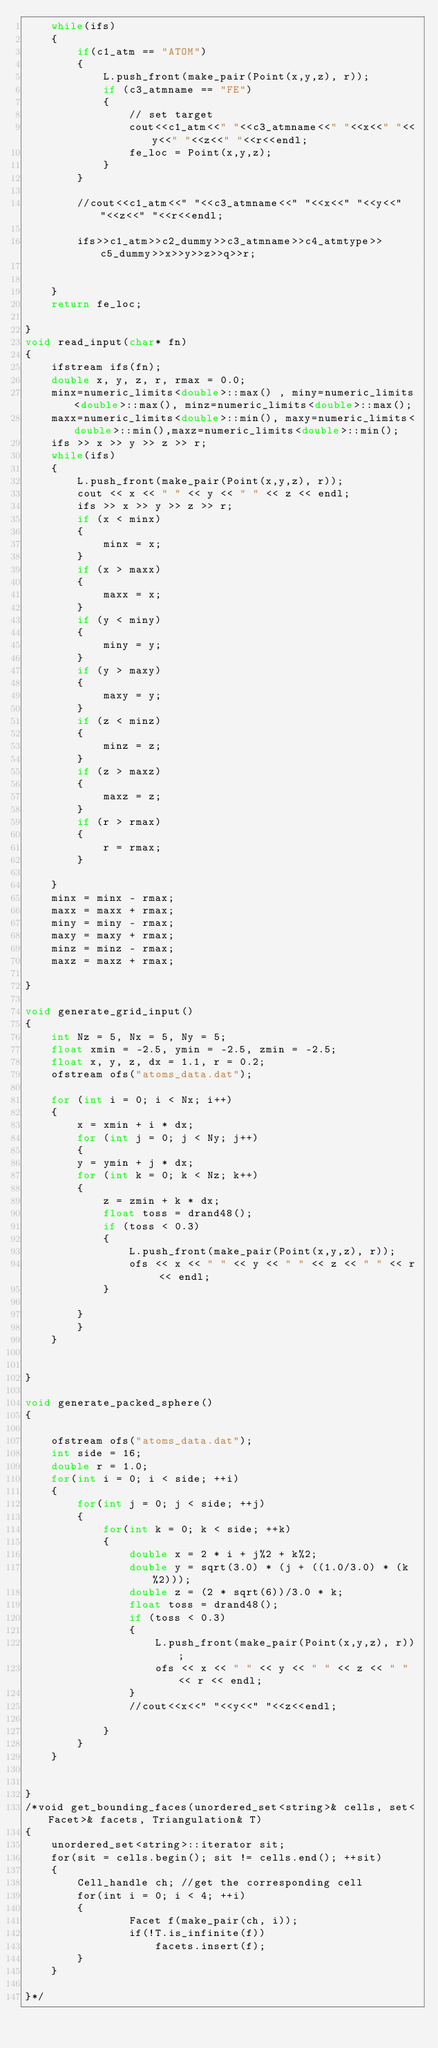<code> <loc_0><loc_0><loc_500><loc_500><_C++_>	while(ifs)
	{
		if(c1_atm == "ATOM")
		{
			L.push_front(make_pair(Point(x,y,z), r));
			if (c3_atmname == "FE")
			{
				// set target
				cout<<c1_atm<<" "<<c3_atmname<<" "<<x<<" "<<y<<" "<<z<<" "<<r<<endl;
				fe_loc = Point(x,y,z);
			}
		}
		
		//cout<<c1_atm<<" "<<c3_atmname<<" "<<x<<" "<<y<<" "<<z<<" "<<r<<endl;
		
		ifs>>c1_atm>>c2_dummy>>c3_atmname>>c4_atmtype>>c5_dummy>>x>>y>>z>>q>>r;


	}
	return fe_loc;

}
void read_input(char* fn)
{
	ifstream ifs(fn);
	double x, y, z, r, rmax = 0.0;
	minx=numeric_limits<double>::max() , miny=numeric_limits<double>::max(), minz=numeric_limits<double>::max();
	maxx=numeric_limits<double>::min(), maxy=numeric_limits<double>::min(),maxz=numeric_limits<double>::min();
	ifs >> x >> y >> z >> r;
	while(ifs)
	{
		L.push_front(make_pair(Point(x,y,z), r));
		cout << x << " " << y << " " << z << endl;
		ifs >> x >> y >> z >> r;
		if (x < minx)
		{
			minx = x;
		}
		if (x > maxx)
		{
			maxx = x;
		}
		if (y < miny)
		{
			miny = y;
		}
		if (y > maxy)
		{
			maxy = y;
		}
		if (z < minz)
		{
			minz = z;
		}
		if (z > maxz)
		{
			maxz = z;
		}
		if (r > rmax)
		{
			r = rmax;
		}

	}
	minx = minx - rmax;
	maxx = maxx + rmax;
	miny = miny - rmax;
	maxy = maxy + rmax;
	minz = minz - rmax;
	maxz = maxz + rmax;

}

void generate_grid_input()
{
	int Nz = 5, Nx = 5, Ny = 5;
	float xmin = -2.5, ymin = -2.5, zmin = -2.5;
	float x, y, z, dx = 1.1, r = 0.2;
	ofstream ofs("atoms_data.dat");

	for (int i = 0; i < Nx; i++)
	{
	    x = xmin + i * dx; 
	    for (int j = 0; j < Ny; j++)
	    {
		y = ymin + j * dx; 
		for (int k = 0; k < Nz; k++)
		{
			z = zmin + k * dx;
			float toss = drand48();
			if (toss < 0.3)
			{
				L.push_front(make_pair(Point(x,y,z), r));
				ofs << x << " " << y << " " << z << " " << r << endl;
			}
			
		}
	    }
	}


}

void generate_packed_sphere()
{

	ofstream ofs("atoms_data.dat");
	int side = 16;
	double r = 1.0;
	for(int i = 0; i < side; ++i)
	{
		for(int j = 0; j < side; ++j)
		{
			for(int k = 0; k < side; ++k)
			{
				double x = 2 * i + j%2 + k%2;
				double y = sqrt(3.0) * (j + ((1.0/3.0) * (k%2)));
				double z = (2 * sqrt(6))/3.0 * k;
				float toss = drand48();
				if (toss < 0.3)
				{
					L.push_front(make_pair(Point(x,y,z), r));
					ofs << x << " " << y << " " << z << " " << r << endl;
				}
				//cout<<x<<" "<<y<<" "<<z<<endl;

			}
		}
	}


}
/*void get_bounding_faces(unordered_set<string>& cells, set<Facet>& facets, Triangulation& T)
{
	unordered_set<string>::iterator sit;
	for(sit = cells.begin(); sit != cells.end(); ++sit)
	{
		Cell_handle ch; //get the corresponding cell
		for(int i = 0; i < 4; ++i)
		{
				Facet f(make_pair(ch, i));
				if(!T.is_infinite(f))
					facets.insert(f);
		}
	}	

}*/

</code> 